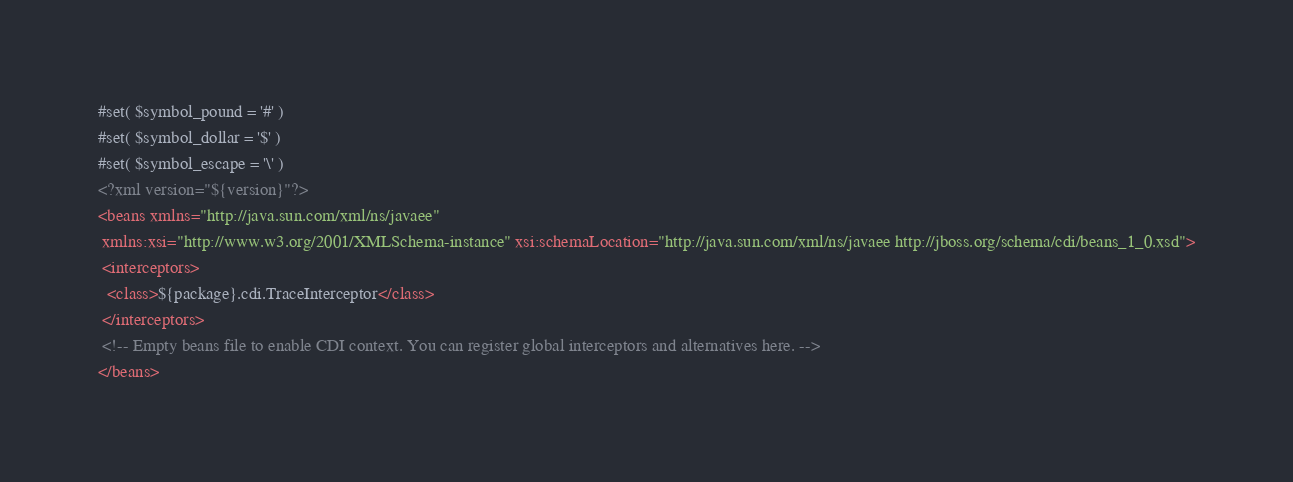<code> <loc_0><loc_0><loc_500><loc_500><_XML_>#set( $symbol_pound = '#' )
#set( $symbol_dollar = '$' )
#set( $symbol_escape = '\' )
<?xml version="${version}"?>
<beans xmlns="http://java.sun.com/xml/ns/javaee"
 xmlns:xsi="http://www.w3.org/2001/XMLSchema-instance" xsi:schemaLocation="http://java.sun.com/xml/ns/javaee http://jboss.org/schema/cdi/beans_1_0.xsd">
 <interceptors>
  <class>${package}.cdi.TraceInterceptor</class>
 </interceptors>
 <!-- Empty beans file to enable CDI context. You can register global interceptors and alternatives here. -->
</beans>
</code> 